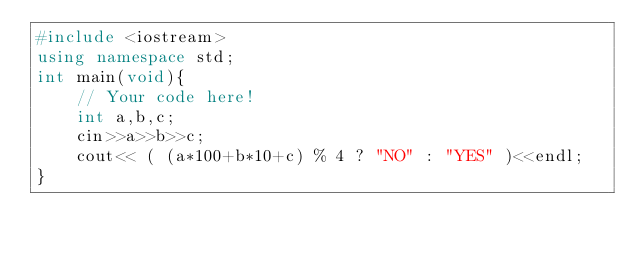<code> <loc_0><loc_0><loc_500><loc_500><_C++_>#include <iostream>
using namespace std;
int main(void){
    // Your code here!
    int a,b,c;
    cin>>a>>b>>c;
    cout<< ( (a*100+b*10+c) % 4 ? "NO" : "YES" )<<endl;
}
</code> 